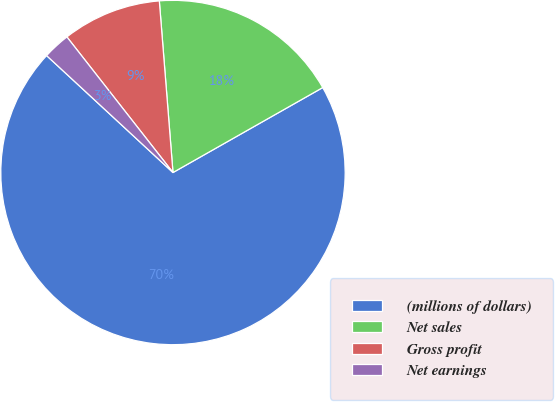Convert chart to OTSL. <chart><loc_0><loc_0><loc_500><loc_500><pie_chart><fcel>(millions of dollars)<fcel>Net sales<fcel>Gross profit<fcel>Net earnings<nl><fcel>70.09%<fcel>18.05%<fcel>9.3%<fcel>2.55%<nl></chart> 